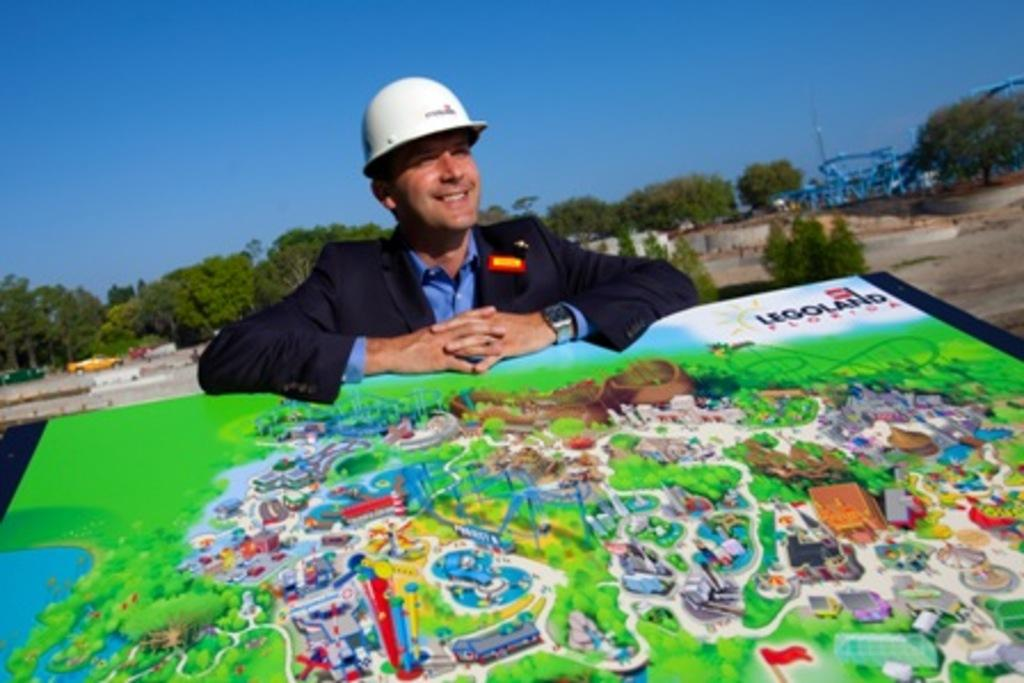Who is present in the image? There is a man in the image. What is the man doing in the image? The man is smiling in the image. What type of clothing is the man wearing? The man is wearing a coat and a shirt in the image. What protective gear is the man wearing? The man is wearing a helmet in the image. What is located at the bottom of the image? There is a map at the bottom of the image. What type of natural scenery can be seen in the image? Trees are visible at the back side of the image, and the sky is visible at the top of the image. Can you see a bear interacting with the man in the image? No, there is no bear present in the image. What is the man's destination for his voyage in the image? The image does not provide information about the man's destination or any voyage he might be on. 